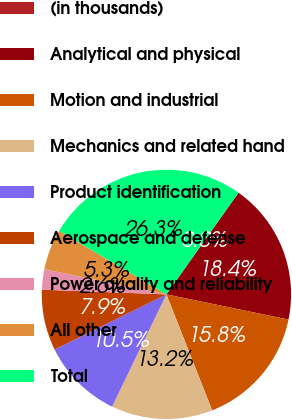<chart> <loc_0><loc_0><loc_500><loc_500><pie_chart><fcel>(in thousands)<fcel>Analytical and physical<fcel>Motion and industrial<fcel>Mechanics and related hand<fcel>Product identification<fcel>Aerospace and defense<fcel>Power quality and reliability<fcel>All other<fcel>Total<nl><fcel>0.01%<fcel>18.42%<fcel>15.79%<fcel>13.16%<fcel>10.53%<fcel>7.9%<fcel>2.64%<fcel>5.27%<fcel>26.31%<nl></chart> 